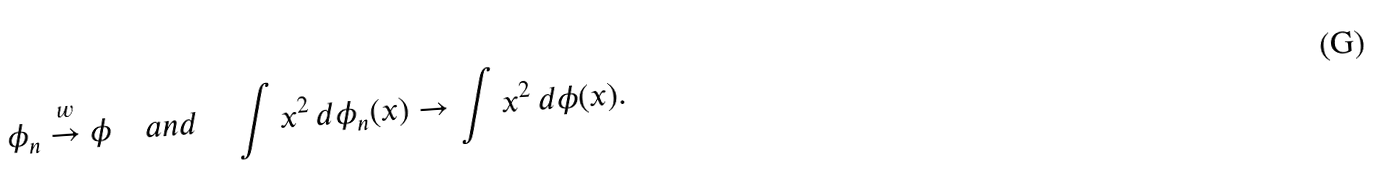Convert formula to latex. <formula><loc_0><loc_0><loc_500><loc_500>\phi _ { n } \stackrel { w } { \rightarrow } \phi \quad a n d \quad \int x ^ { 2 } \, d \phi _ { n } ( x ) \rightarrow \int x ^ { 2 } \, d \phi ( x ) .</formula> 